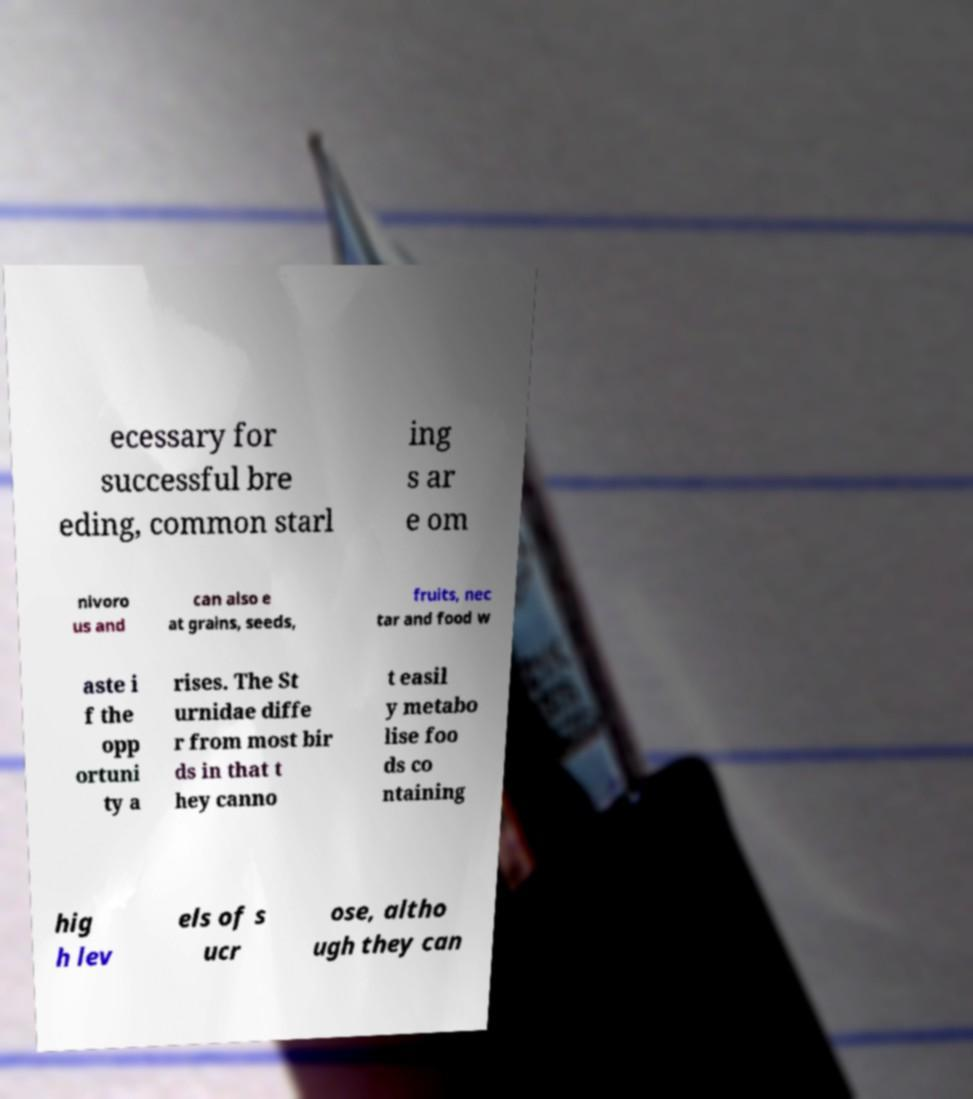Can you accurately transcribe the text from the provided image for me? ecessary for successful bre eding, common starl ing s ar e om nivoro us and can also e at grains, seeds, fruits, nec tar and food w aste i f the opp ortuni ty a rises. The St urnidae diffe r from most bir ds in that t hey canno t easil y metabo lise foo ds co ntaining hig h lev els of s ucr ose, altho ugh they can 